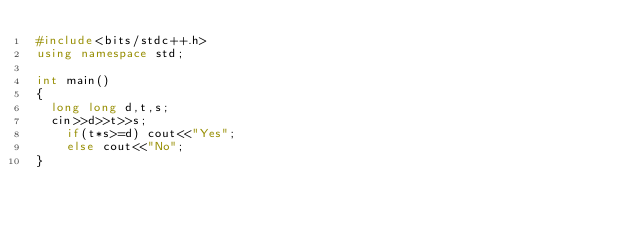<code> <loc_0><loc_0><loc_500><loc_500><_C++_>#include<bits/stdc++.h>
using namespace std;

int main()
{
	long long d,t,s;
	cin>>d>>t>>s;
    if(t*s>=d) cout<<"Yes";
    else cout<<"No";
}
</code> 